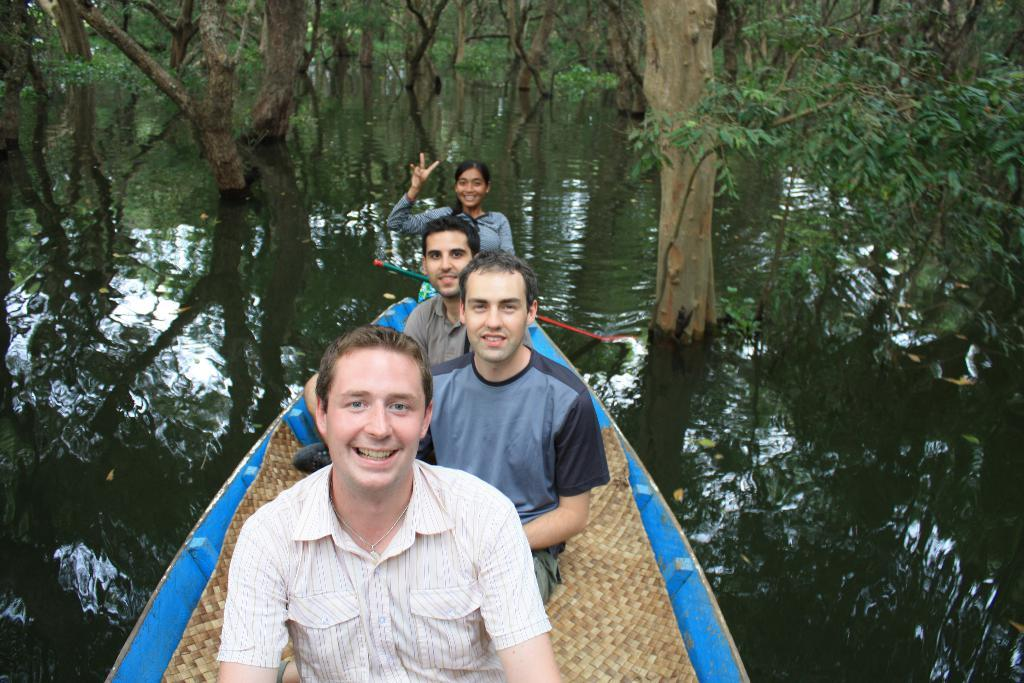What are the people in the image doing? The people in the image are sitting in a boat. Where is the boat located? The boat is on the surface of water. What can be seen in the background of the image? There are trees visible at the top of the image. What type of vase is being used to show off the people's skin in the image? There is no vase or focus on people's skin in the image; it features people sitting in a boat on the water. 